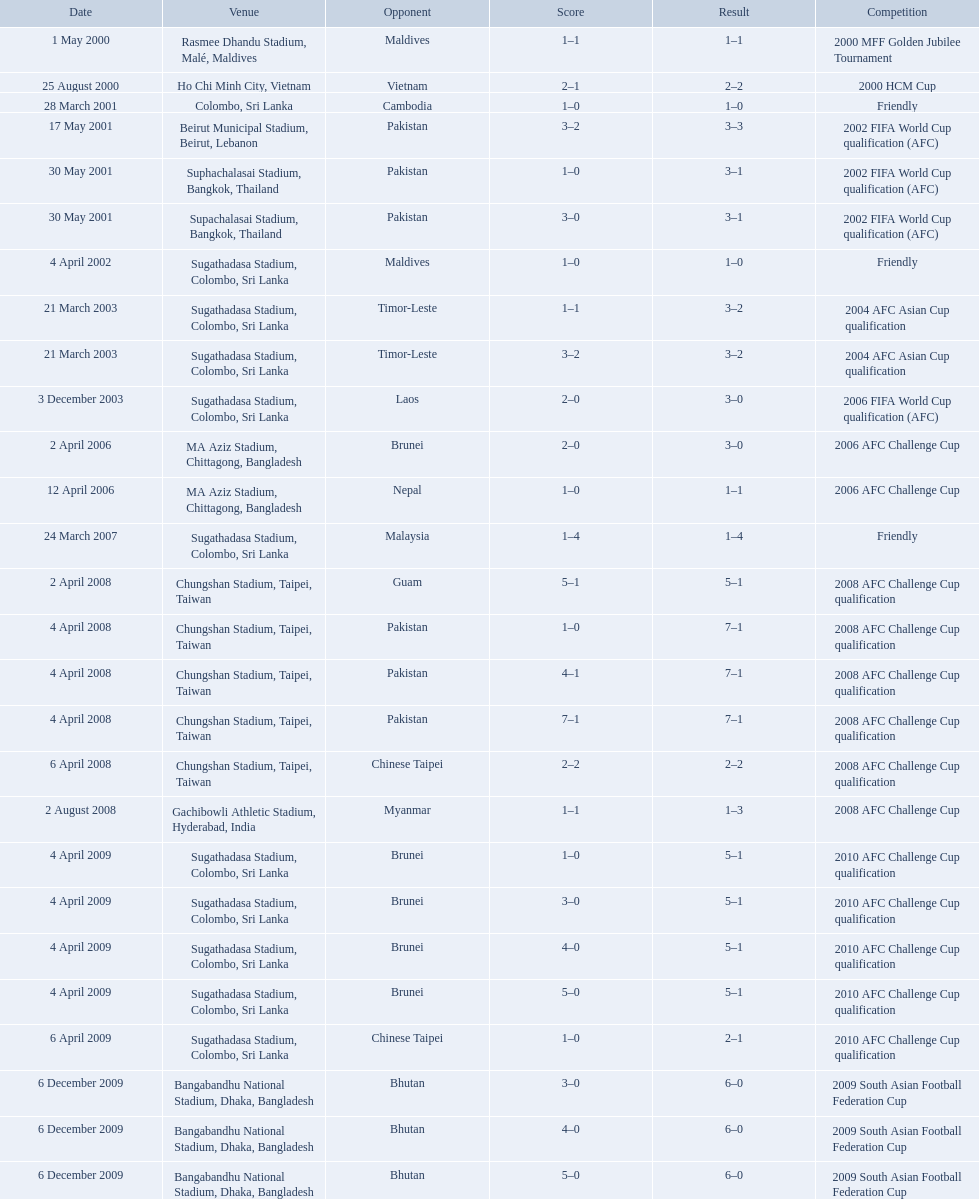How many venues are in the table? 27. Which one is the top listed? Rasmee Dhandu Stadium, Malé, Maldives. What are the venues Rasmee Dhandu Stadium, Malé, Maldives, Ho Chi Minh City, Vietnam, Colombo, Sri Lanka, Beirut Municipal Stadium, Beirut, Lebanon, Suphachalasai Stadium, Bangkok, Thailand, Supachalasai Stadium, Bangkok, Thailand, Sugathadasa Stadium, Colombo, Sri Lanka, Sugathadasa Stadium, Colombo, Sri Lanka, Sugathadasa Stadium, Colombo, Sri Lanka, Sugathadasa Stadium, Colombo, Sri Lanka, MA Aziz Stadium, Chittagong, Bangladesh, MA Aziz Stadium, Chittagong, Bangladesh, Sugathadasa Stadium, Colombo, Sri Lanka, Chungshan Stadium, Taipei, Taiwan, Chungshan Stadium, Taipei, Taiwan, Chungshan Stadium, Taipei, Taiwan, Chungshan Stadium, Taipei, Taiwan, Chungshan Stadium, Taipei, Taiwan, Gachibowli Athletic Stadium, Hyderabad, India, Sugathadasa Stadium, Colombo, Sri Lanka, Sugathadasa Stadium, Colombo, Sri Lanka, Sugathadasa Stadium, Colombo, Sri Lanka, Sugathadasa Stadium, Colombo, Sri Lanka, Sugathadasa Stadium, Colombo, Sri Lanka, Bangabandhu National Stadium, Dhaka, Bangladesh, Bangabandhu National Stadium, Dhaka, Bangladesh, Bangabandhu National Stadium, Dhaka, Bangladesh. What are the #'s? 1., 2., 3., 4., 5., 6., 7., 8., 9., 10., 11., 12., 13., 14., 15., 16., 17., 18., 19., 20., 21., 22., 23., 24., 25., 26., 27. Would you mind parsing the complete table? {'header': ['Date', 'Venue', 'Opponent', 'Score', 'Result', 'Competition'], 'rows': [['1 May 2000', 'Rasmee Dhandu Stadium, Malé, Maldives', 'Maldives', '1–1', '1–1', '2000 MFF Golden Jubilee Tournament'], ['25 August 2000', 'Ho Chi Minh City, Vietnam', 'Vietnam', '2–1', '2–2', '2000 HCM Cup'], ['28 March 2001', 'Colombo, Sri Lanka', 'Cambodia', '1–0', '1–0', 'Friendly'], ['17 May 2001', 'Beirut Municipal Stadium, Beirut, Lebanon', 'Pakistan', '3–2', '3–3', '2002 FIFA World Cup qualification (AFC)'], ['30 May 2001', 'Suphachalasai Stadium, Bangkok, Thailand', 'Pakistan', '1–0', '3–1', '2002 FIFA World Cup qualification (AFC)'], ['30 May 2001', 'Supachalasai Stadium, Bangkok, Thailand', 'Pakistan', '3–0', '3–1', '2002 FIFA World Cup qualification (AFC)'], ['4 April 2002', 'Sugathadasa Stadium, Colombo, Sri Lanka', 'Maldives', '1–0', '1–0', 'Friendly'], ['21 March 2003', 'Sugathadasa Stadium, Colombo, Sri Lanka', 'Timor-Leste', '1–1', '3–2', '2004 AFC Asian Cup qualification'], ['21 March 2003', 'Sugathadasa Stadium, Colombo, Sri Lanka', 'Timor-Leste', '3–2', '3–2', '2004 AFC Asian Cup qualification'], ['3 December 2003', 'Sugathadasa Stadium, Colombo, Sri Lanka', 'Laos', '2–0', '3–0', '2006 FIFA World Cup qualification (AFC)'], ['2 April 2006', 'MA Aziz Stadium, Chittagong, Bangladesh', 'Brunei', '2–0', '3–0', '2006 AFC Challenge Cup'], ['12 April 2006', 'MA Aziz Stadium, Chittagong, Bangladesh', 'Nepal', '1–0', '1–1', '2006 AFC Challenge Cup'], ['24 March 2007', 'Sugathadasa Stadium, Colombo, Sri Lanka', 'Malaysia', '1–4', '1–4', 'Friendly'], ['2 April 2008', 'Chungshan Stadium, Taipei, Taiwan', 'Guam', '5–1', '5–1', '2008 AFC Challenge Cup qualification'], ['4 April 2008', 'Chungshan Stadium, Taipei, Taiwan', 'Pakistan', '1–0', '7–1', '2008 AFC Challenge Cup qualification'], ['4 April 2008', 'Chungshan Stadium, Taipei, Taiwan', 'Pakistan', '4–1', '7–1', '2008 AFC Challenge Cup qualification'], ['4 April 2008', 'Chungshan Stadium, Taipei, Taiwan', 'Pakistan', '7–1', '7–1', '2008 AFC Challenge Cup qualification'], ['6 April 2008', 'Chungshan Stadium, Taipei, Taiwan', 'Chinese Taipei', '2–2', '2–2', '2008 AFC Challenge Cup qualification'], ['2 August 2008', 'Gachibowli Athletic Stadium, Hyderabad, India', 'Myanmar', '1–1', '1–3', '2008 AFC Challenge Cup'], ['4 April 2009', 'Sugathadasa Stadium, Colombo, Sri Lanka', 'Brunei', '1–0', '5–1', '2010 AFC Challenge Cup qualification'], ['4 April 2009', 'Sugathadasa Stadium, Colombo, Sri Lanka', 'Brunei', '3–0', '5–1', '2010 AFC Challenge Cup qualification'], ['4 April 2009', 'Sugathadasa Stadium, Colombo, Sri Lanka', 'Brunei', '4–0', '5–1', '2010 AFC Challenge Cup qualification'], ['4 April 2009', 'Sugathadasa Stadium, Colombo, Sri Lanka', 'Brunei', '5–0', '5–1', '2010 AFC Challenge Cup qualification'], ['6 April 2009', 'Sugathadasa Stadium, Colombo, Sri Lanka', 'Chinese Taipei', '1–0', '2–1', '2010 AFC Challenge Cup qualification'], ['6 December 2009', 'Bangabandhu National Stadium, Dhaka, Bangladesh', 'Bhutan', '3–0', '6–0', '2009 South Asian Football Federation Cup'], ['6 December 2009', 'Bangabandhu National Stadium, Dhaka, Bangladesh', 'Bhutan', '4–0', '6–0', '2009 South Asian Football Federation Cup'], ['6 December 2009', 'Bangabandhu National Stadium, Dhaka, Bangladesh', 'Bhutan', '5–0', '6–0', '2009 South Asian Football Federation Cup']]} Which one is #1? Rasmee Dhandu Stadium, Malé, Maldives. 